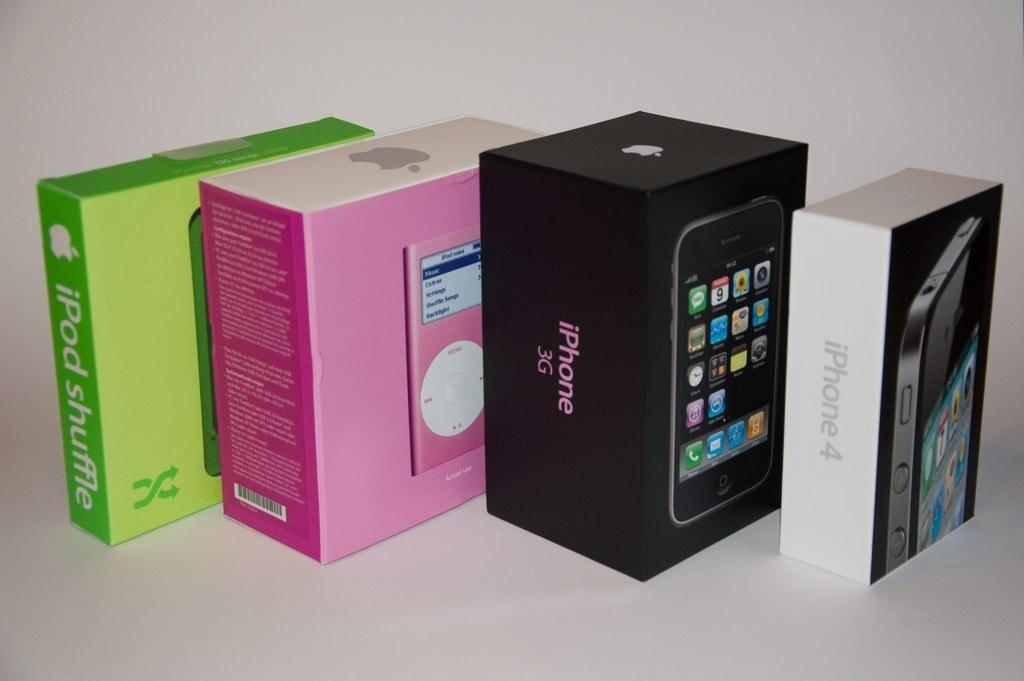<image>
Write a terse but informative summary of the picture. Boxes of electronics lined up next to one another with the iPhone4 in the front. 